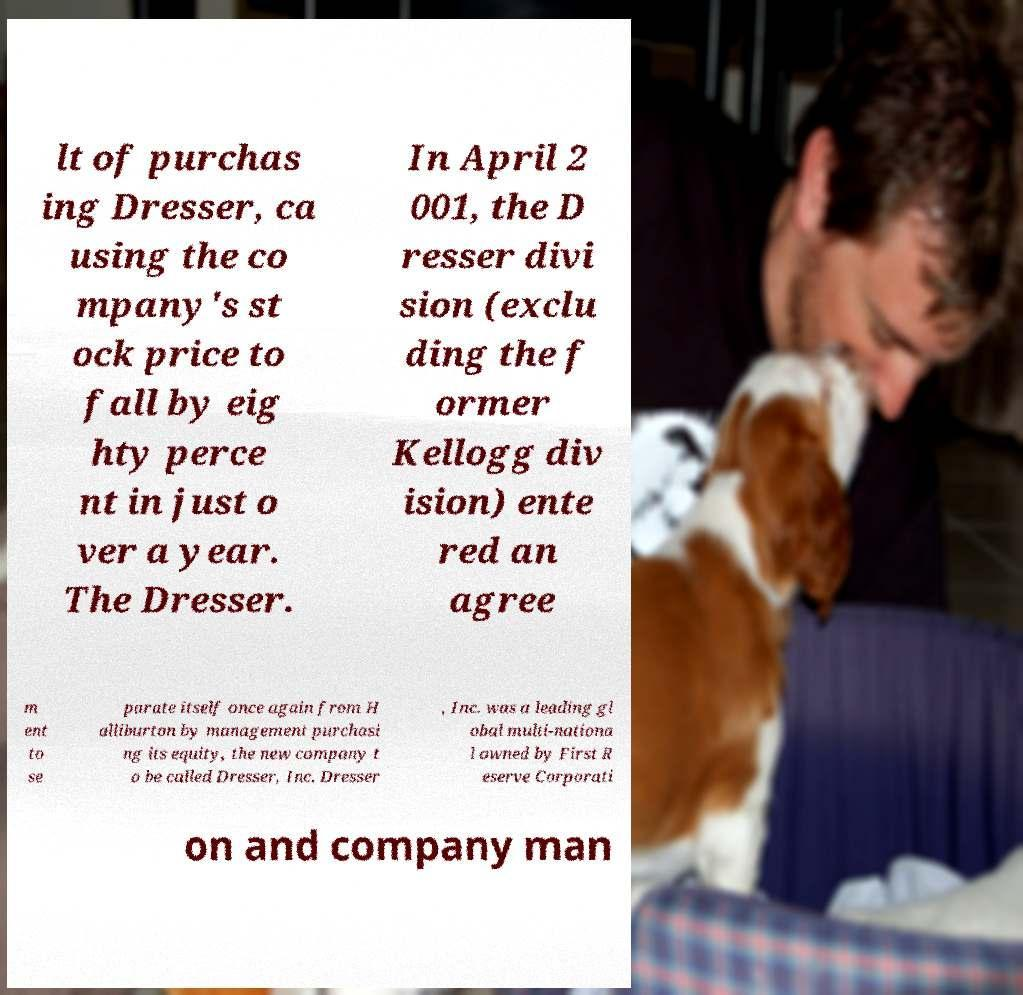For documentation purposes, I need the text within this image transcribed. Could you provide that? lt of purchas ing Dresser, ca using the co mpany's st ock price to fall by eig hty perce nt in just o ver a year. The Dresser. In April 2 001, the D resser divi sion (exclu ding the f ormer Kellogg div ision) ente red an agree m ent to se parate itself once again from H alliburton by management purchasi ng its equity, the new company t o be called Dresser, Inc. Dresser , Inc. was a leading gl obal multi-nationa l owned by First R eserve Corporati on and company man 